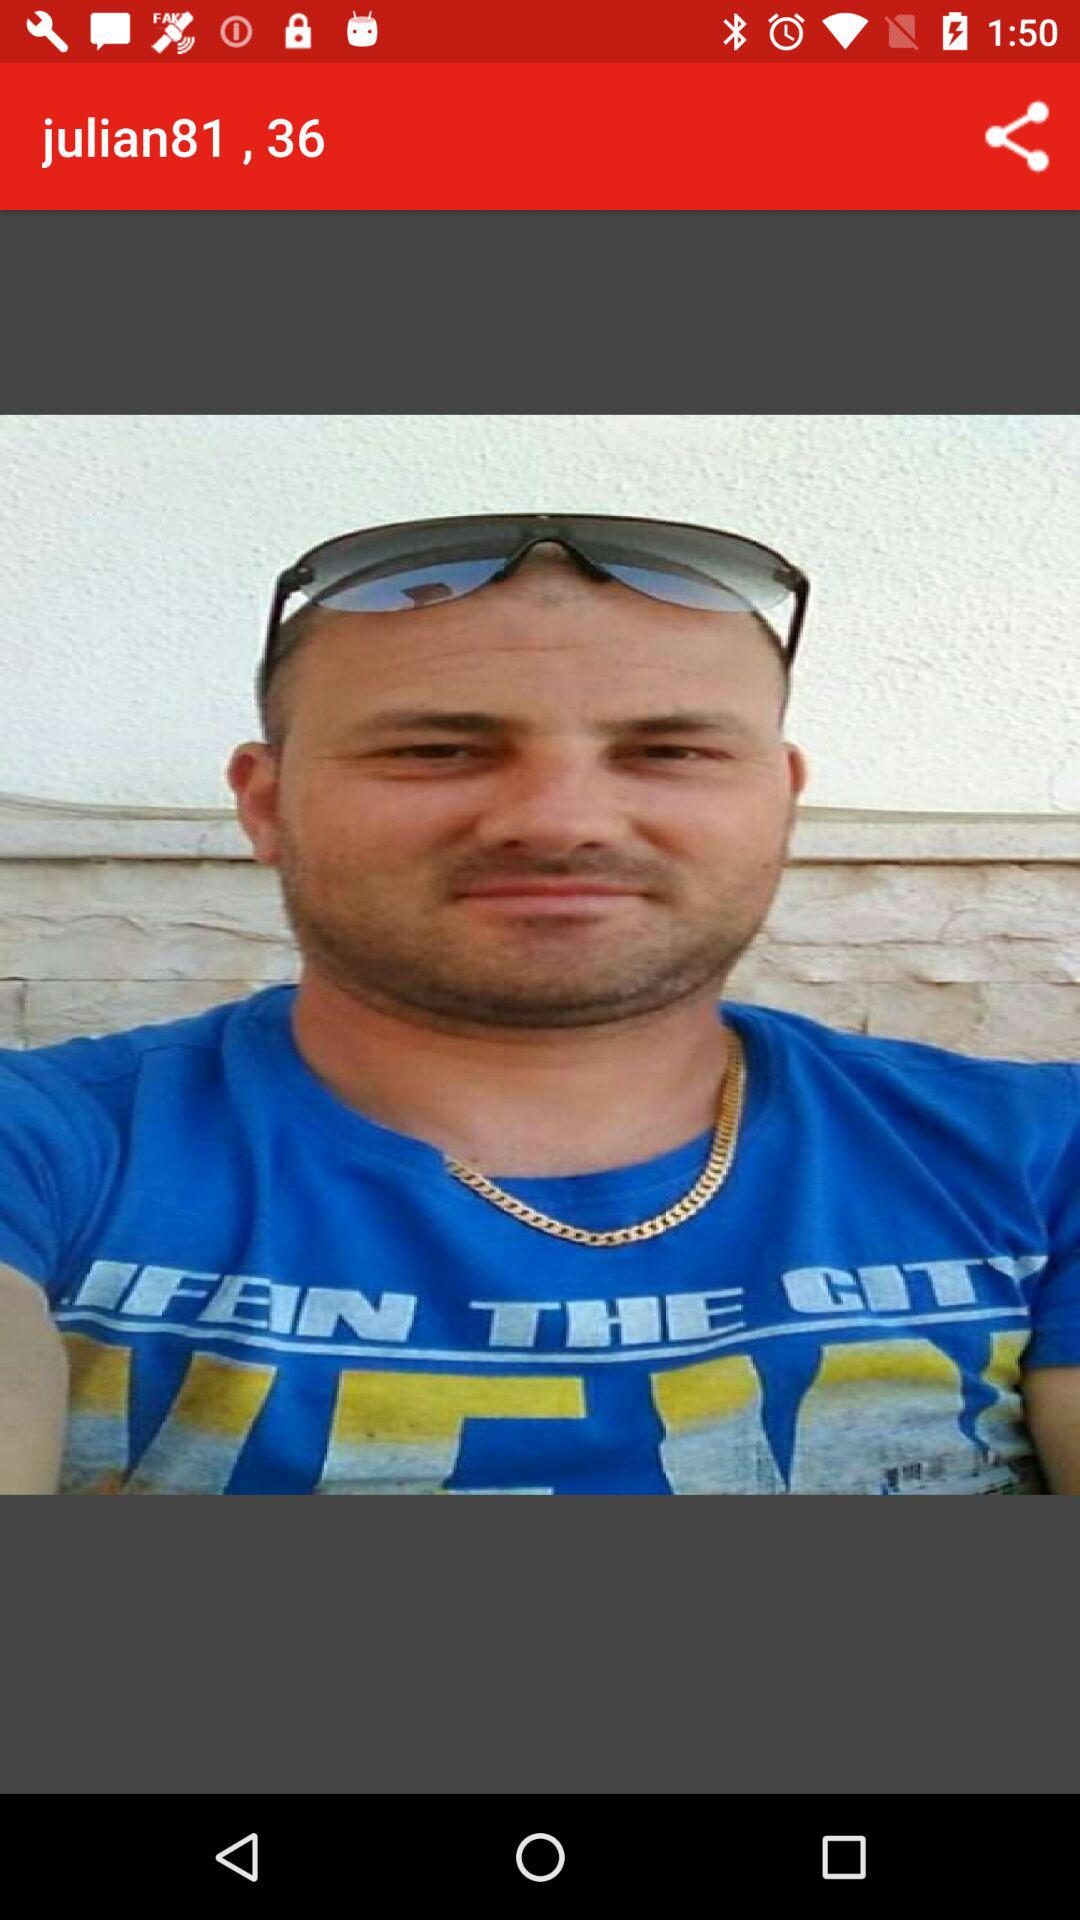How to pronounce the person name?
When the provided information is insufficient, respond with <no answer>. <no answer> 